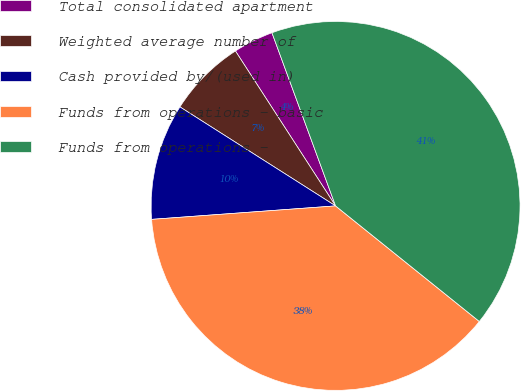Convert chart to OTSL. <chart><loc_0><loc_0><loc_500><loc_500><pie_chart><fcel>Total consolidated apartment<fcel>Weighted average number of<fcel>Cash provided by/(used in)<fcel>Funds from operations - basic<fcel>Funds from operations -<nl><fcel>3.53%<fcel>6.85%<fcel>10.18%<fcel>38.06%<fcel>41.38%<nl></chart> 